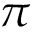Convert formula to latex. <formula><loc_0><loc_0><loc_500><loc_500>\pi</formula> 